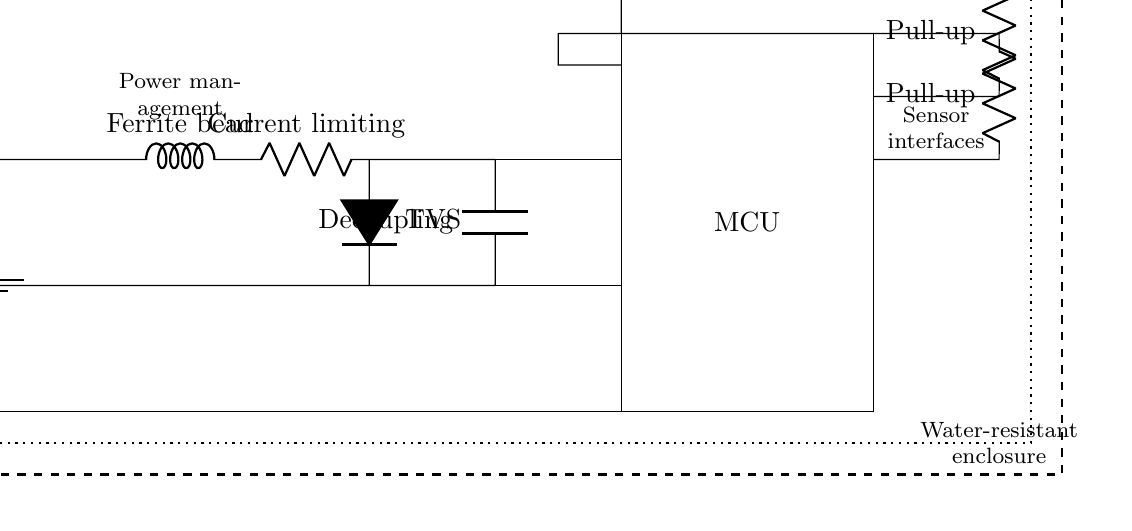What is the main power supply of this circuit? The main power supply in the circuit is a battery, indicated by the symbol labeled as Vcc. This supplies the necessary voltage for the entire system.
Answer: battery What does the ferrite bead do in this design? The ferrite bead is used for filtering high-frequency noise in the circuit, allowing it to stabilize the power supply and improve performance.
Answer: Filtering Which component is used for voltage regulation? The voltage regulator is not explicitly labeled with a specific type in this diagram but is implied by the presence of the inductor and resistor that manage voltage levels for the microcontroller.
Answer: Voltage regulator What type of coating is shown for waterproofing? The circuit diagram indicates the use of a conformal coating, represented by the dotted rectangle surrounding the components, which protects them from moisture and corrosion.
Answer: conformal coating What is the purpose of the TVS diode in this circuit? The TVS diode, shown in the circuit, is used for transient voltage suppression, preventing voltage spikes that could damage sensitive components downstream, such as the microcontroller.
Answer: Transient suppression How many resistors are in this circuit? There are three resistors used in this circuit, as shown connected to the pull-up configurations for the sensor connections.
Answer: three What is the function of the decoupling capacitor? The decoupling capacitor helps to stabilize the voltage supplied to the microcontroller by filtering out any noise that may affect the performance of the MCU, maintaining a clean power signal.
Answer: Stabilization 